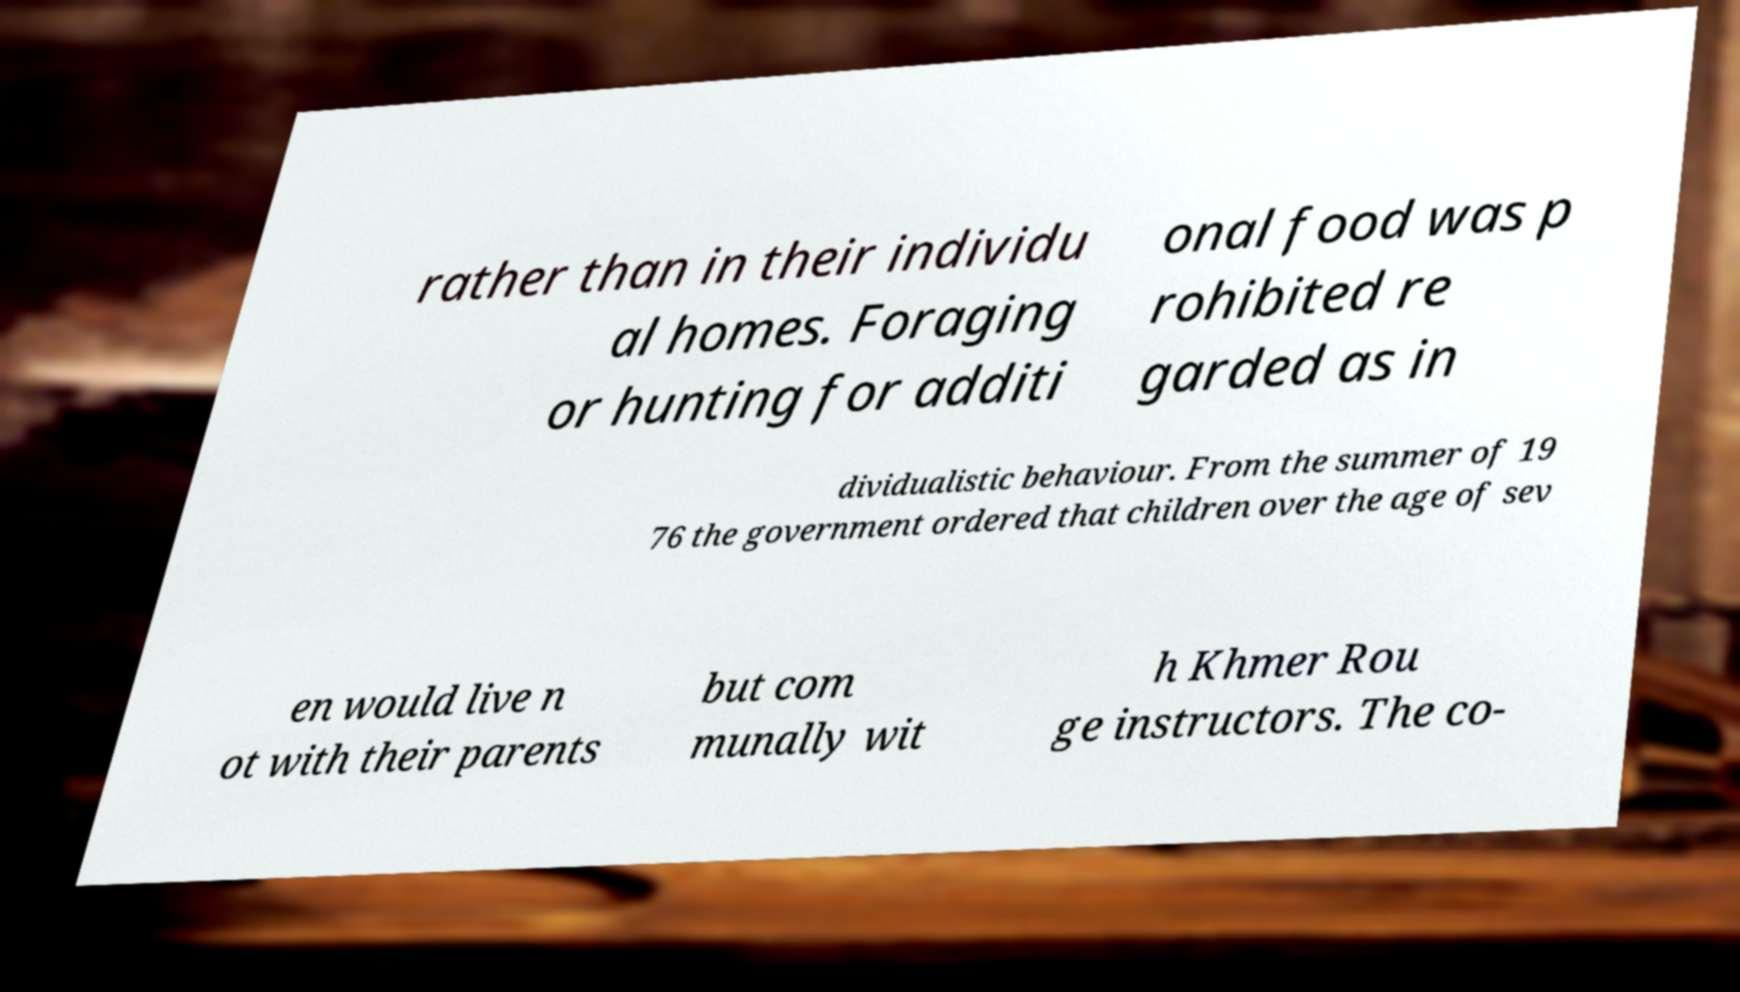Please identify and transcribe the text found in this image. rather than in their individu al homes. Foraging or hunting for additi onal food was p rohibited re garded as in dividualistic behaviour. From the summer of 19 76 the government ordered that children over the age of sev en would live n ot with their parents but com munally wit h Khmer Rou ge instructors. The co- 